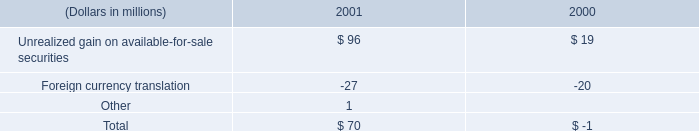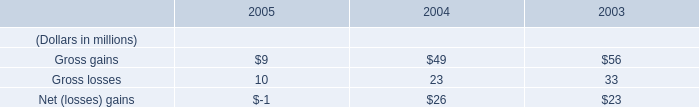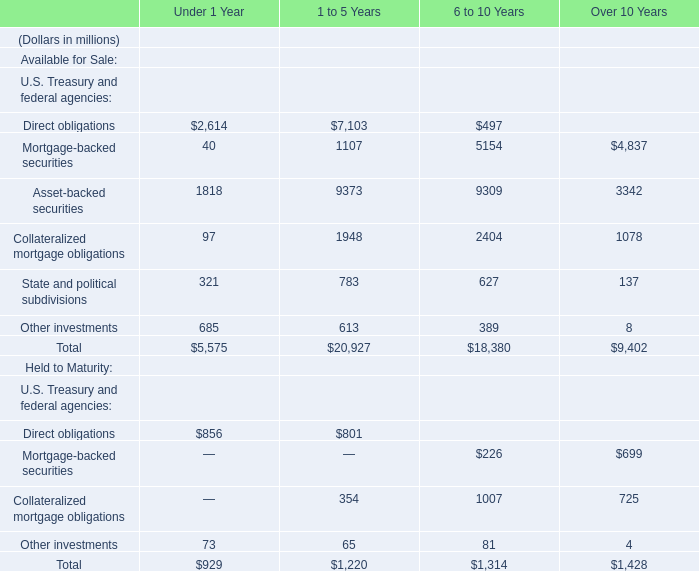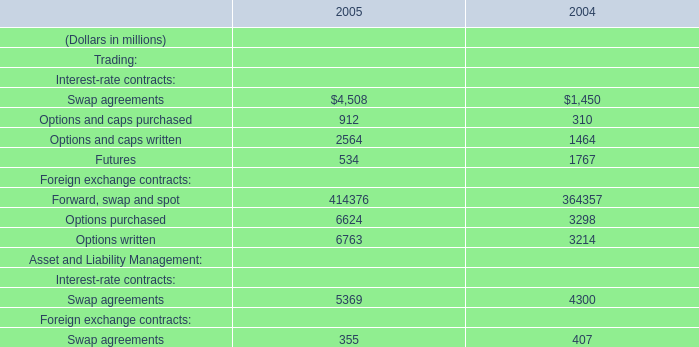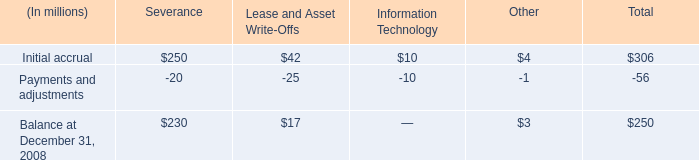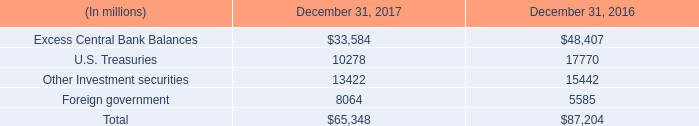what is the percent change excess central bank balances from 2016 to 2017? 
Computations: (1 - (33584 / 48407))
Answer: 0.30622. 